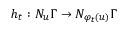Convert formula to latex. <formula><loc_0><loc_0><loc_500><loc_500>h _ { t } \colon N _ { u } \Gamma \to N _ { \varphi _ { t } ( u ) } \Gamma</formula> 